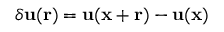<formula> <loc_0><loc_0><loc_500><loc_500>\delta { u } ( { r } ) = { u } ( { x } + r ) - { u } ( { x } )</formula> 